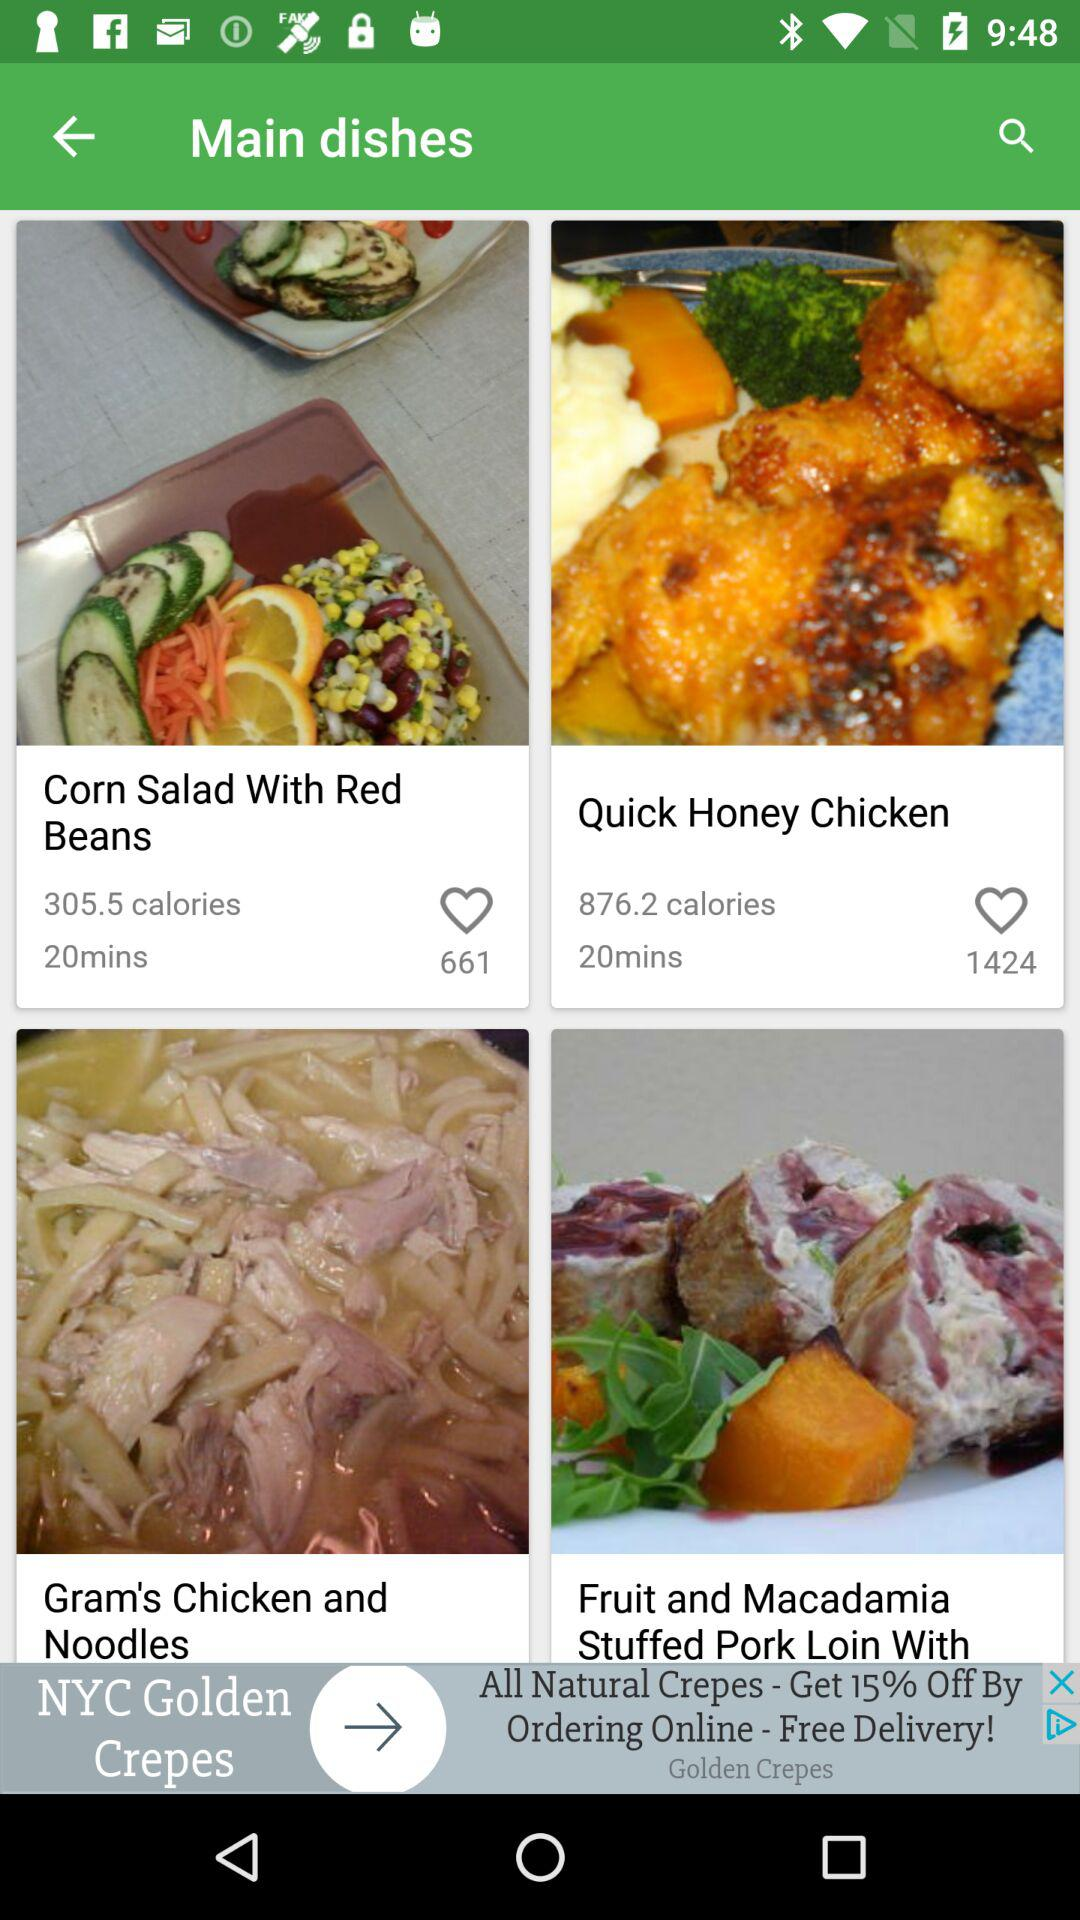What's the duration for "Quick Honey Chicken" dish? The duration is 20 minutes. 